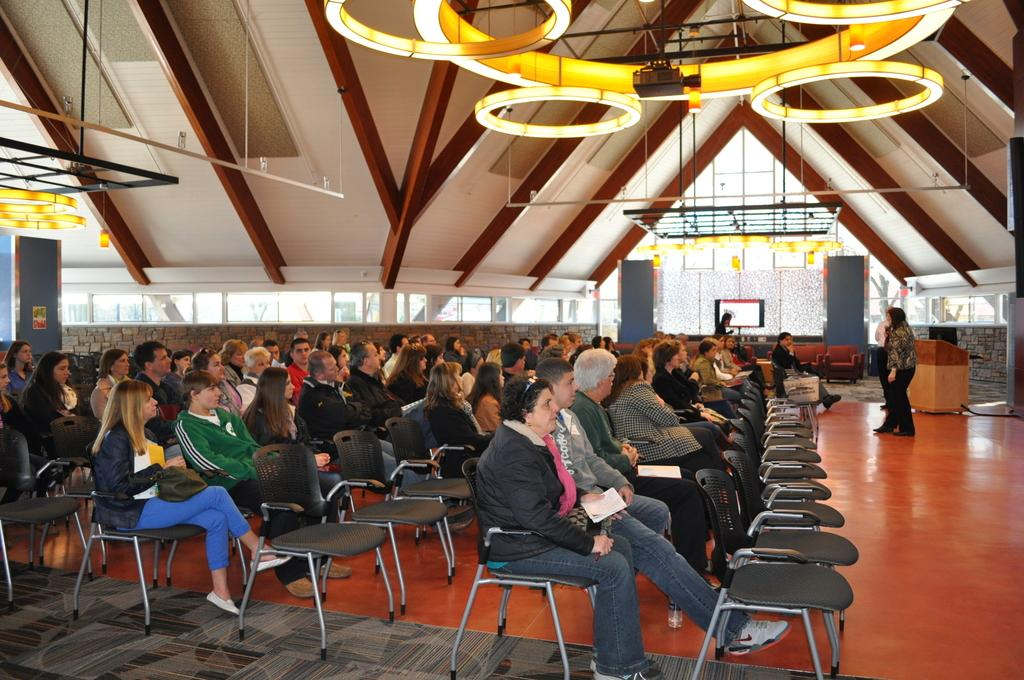How many individuals are present in the image? There are many people in the image. What are the people doing in the image? The people are sitting on chairs. What type of clam is being served at the table in the image? There is no table or clam present in the image; it only shows people sitting on chairs. 